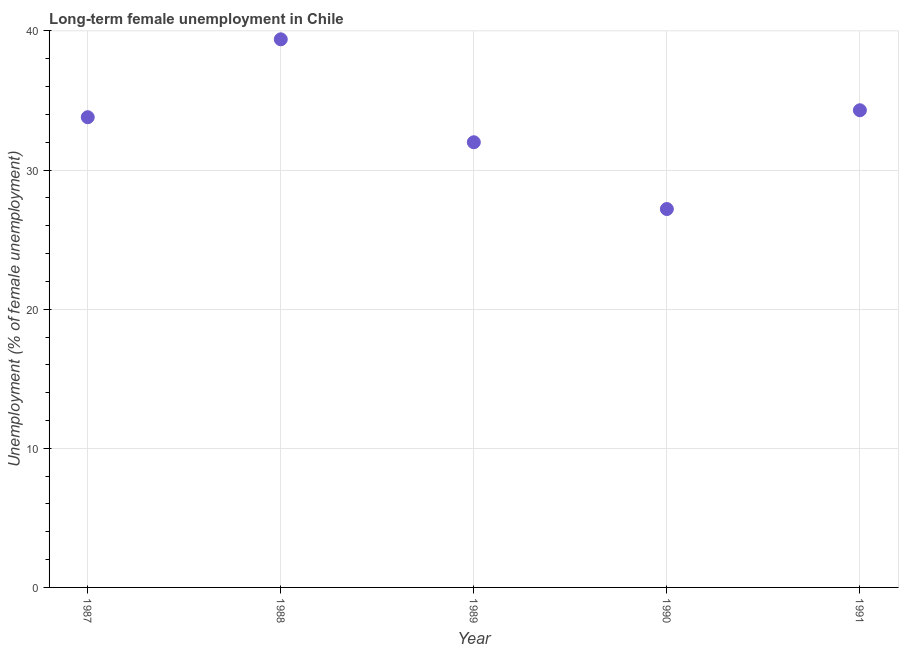What is the long-term female unemployment in 1987?
Give a very brief answer. 33.8. Across all years, what is the maximum long-term female unemployment?
Make the answer very short. 39.4. Across all years, what is the minimum long-term female unemployment?
Your response must be concise. 27.2. In which year was the long-term female unemployment minimum?
Your answer should be very brief. 1990. What is the sum of the long-term female unemployment?
Offer a very short reply. 166.7. What is the difference between the long-term female unemployment in 1988 and 1991?
Give a very brief answer. 5.1. What is the average long-term female unemployment per year?
Ensure brevity in your answer.  33.34. What is the median long-term female unemployment?
Offer a terse response. 33.8. What is the ratio of the long-term female unemployment in 1987 to that in 1991?
Your answer should be very brief. 0.99. Is the long-term female unemployment in 1989 less than that in 1991?
Offer a terse response. Yes. What is the difference between the highest and the second highest long-term female unemployment?
Offer a very short reply. 5.1. Is the sum of the long-term female unemployment in 1990 and 1991 greater than the maximum long-term female unemployment across all years?
Make the answer very short. Yes. What is the difference between the highest and the lowest long-term female unemployment?
Offer a terse response. 12.2. In how many years, is the long-term female unemployment greater than the average long-term female unemployment taken over all years?
Your response must be concise. 3. What is the difference between two consecutive major ticks on the Y-axis?
Offer a very short reply. 10. Are the values on the major ticks of Y-axis written in scientific E-notation?
Make the answer very short. No. What is the title of the graph?
Offer a very short reply. Long-term female unemployment in Chile. What is the label or title of the Y-axis?
Your response must be concise. Unemployment (% of female unemployment). What is the Unemployment (% of female unemployment) in 1987?
Provide a succinct answer. 33.8. What is the Unemployment (% of female unemployment) in 1988?
Your answer should be compact. 39.4. What is the Unemployment (% of female unemployment) in 1990?
Provide a succinct answer. 27.2. What is the Unemployment (% of female unemployment) in 1991?
Offer a very short reply. 34.3. What is the difference between the Unemployment (% of female unemployment) in 1987 and 1988?
Your response must be concise. -5.6. What is the difference between the Unemployment (% of female unemployment) in 1987 and 1989?
Offer a very short reply. 1.8. What is the difference between the Unemployment (% of female unemployment) in 1987 and 1991?
Your response must be concise. -0.5. What is the difference between the Unemployment (% of female unemployment) in 1988 and 1989?
Provide a short and direct response. 7.4. What is the difference between the Unemployment (% of female unemployment) in 1988 and 1990?
Your response must be concise. 12.2. What is the difference between the Unemployment (% of female unemployment) in 1989 and 1990?
Offer a very short reply. 4.8. What is the difference between the Unemployment (% of female unemployment) in 1989 and 1991?
Your answer should be compact. -2.3. What is the ratio of the Unemployment (% of female unemployment) in 1987 to that in 1988?
Provide a succinct answer. 0.86. What is the ratio of the Unemployment (% of female unemployment) in 1987 to that in 1989?
Offer a very short reply. 1.06. What is the ratio of the Unemployment (% of female unemployment) in 1987 to that in 1990?
Keep it short and to the point. 1.24. What is the ratio of the Unemployment (% of female unemployment) in 1988 to that in 1989?
Keep it short and to the point. 1.23. What is the ratio of the Unemployment (% of female unemployment) in 1988 to that in 1990?
Your answer should be very brief. 1.45. What is the ratio of the Unemployment (% of female unemployment) in 1988 to that in 1991?
Make the answer very short. 1.15. What is the ratio of the Unemployment (% of female unemployment) in 1989 to that in 1990?
Your response must be concise. 1.18. What is the ratio of the Unemployment (% of female unemployment) in 1989 to that in 1991?
Make the answer very short. 0.93. What is the ratio of the Unemployment (% of female unemployment) in 1990 to that in 1991?
Make the answer very short. 0.79. 